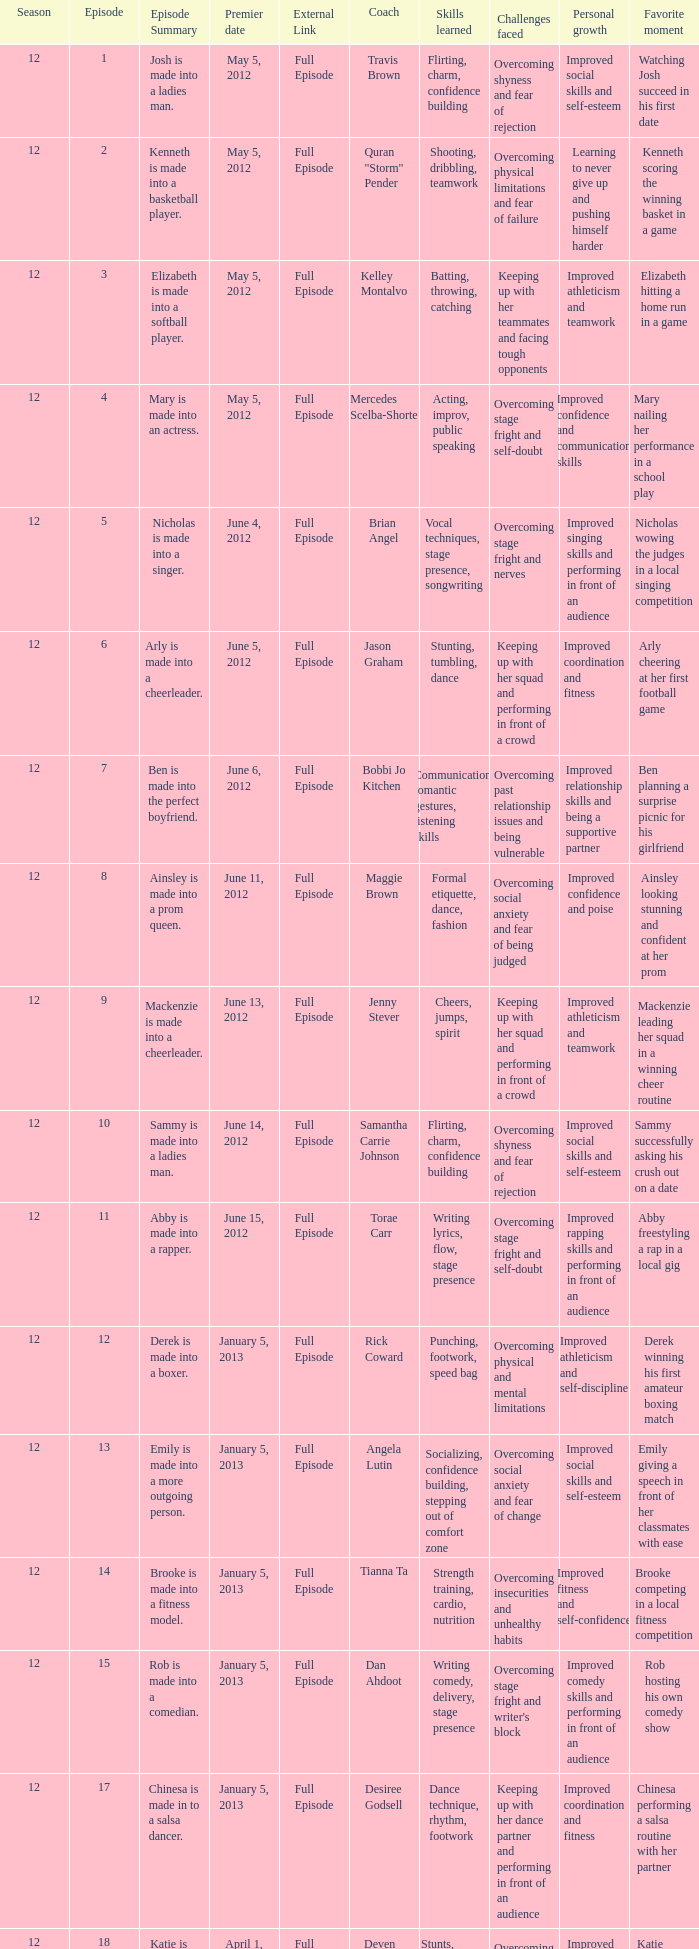Name the episode summary for torae carr Abby is made into a rapper. 